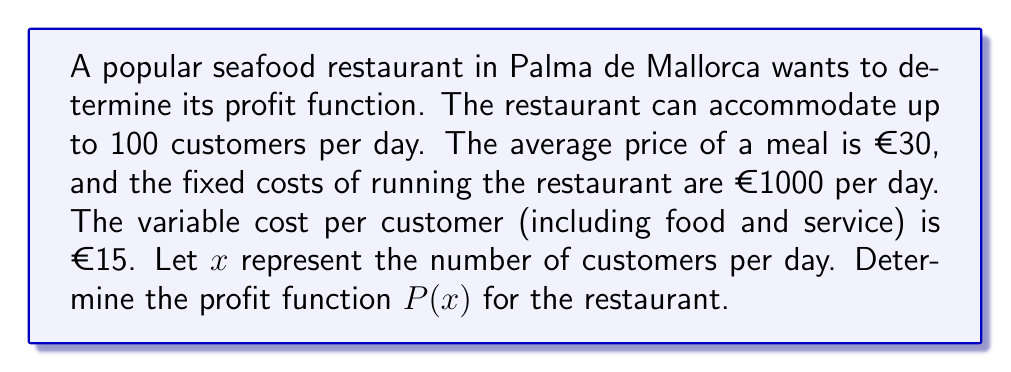Can you answer this question? To determine the profit function, we need to consider the revenue and costs:

1. Revenue:
   - Average price per meal: €30
   - Number of customers: $x$
   - Revenue function: $R(x) = 30x$

2. Costs:
   - Fixed costs: €1000 per day
   - Variable costs: €15 per customer
   - Total cost function: $C(x) = 1000 + 15x$

3. Profit function:
   Profit is the difference between revenue and costs.
   $$P(x) = R(x) - C(x)$$
   
   Substituting the functions:
   $$P(x) = 30x - (1000 + 15x)$$
   
   Simplifying:
   $$P(x) = 30x - 1000 - 15x$$
   $$P(x) = 15x - 1000$$

Therefore, the profit function for the restaurant is $P(x) = 15x - 1000$, where $x$ is the number of customers per day, and $0 \leq x \leq 100$ (since the restaurant can accommodate up to 100 customers).
Answer: $P(x) = 15x - 1000$, where $0 \leq x \leq 100$ 